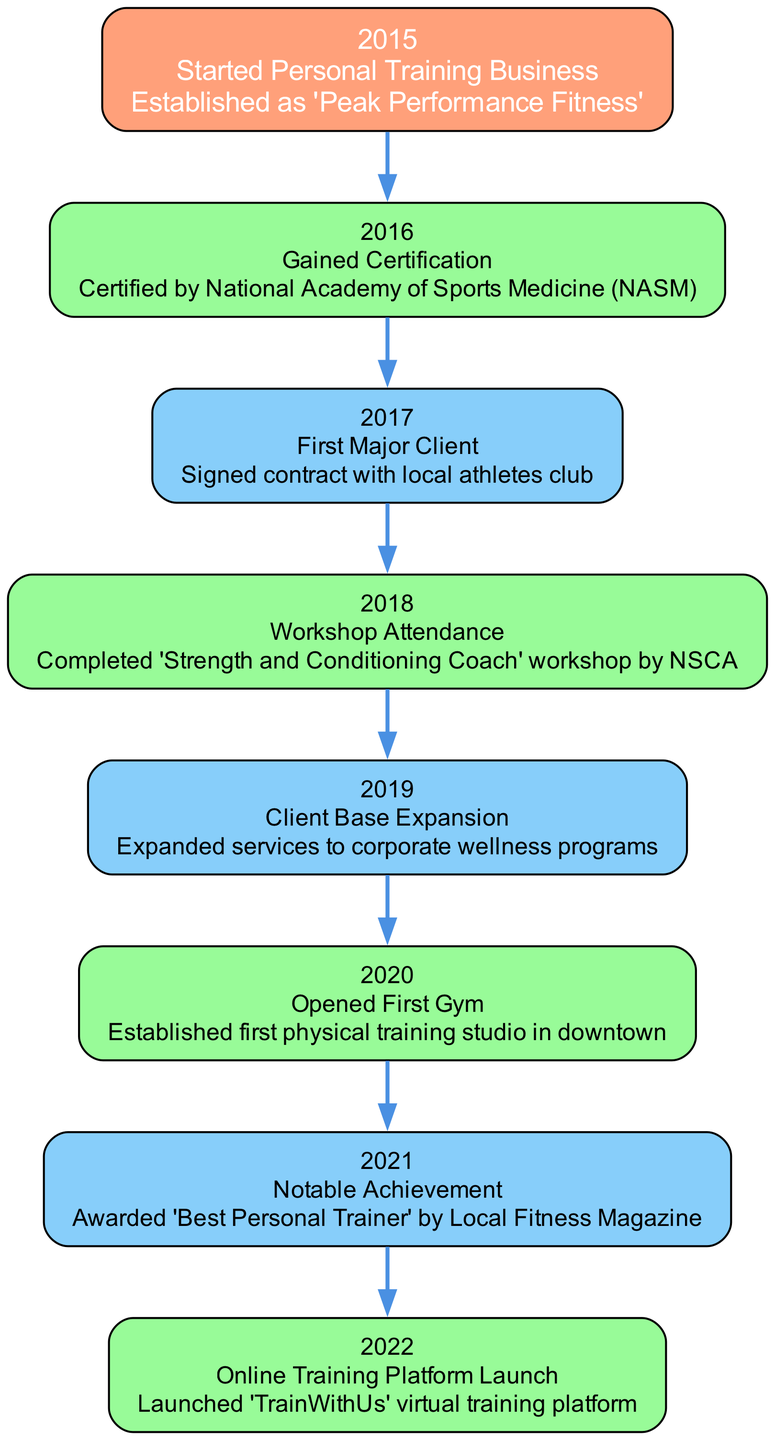What year was the personal training business started? The diagram indicates that the inception of the personal training business occurred in 2015. This can be found at the top node labeled "Inception."
Answer: 2015 How many milestones are listed in the diagram? The diagram contains a total of 7 milestones, including the inception year. Counting the milestone nodes from the diagram shows each significant event in the growth timeline after the inception year.
Answer: 7 What event took place in 2019? The diagram specifically states the event in 2019 is "Client Base Expansion." This node outlines the growth phase in which the business expanded its services.
Answer: Client Base Expansion What was the notable achievement in 2021? The diagram reveals that the notable achievement in 2021 was being awarded "Best Personal Trainer" by Local Fitness Magazine. This information can be found in the corresponding milestone node.
Answer: Awarded 'Best Personal Trainer' What is the last milestone mentioned in the timeline? The final milestone listed in the diagram is the "Online Training Platform Launch," which occurred in the year 2022. This is indicated towards the bottom of the milestones sequence in the diagram.
Answer: Online Training Platform Launch Which workshop did the trainer complete in 2018? The diagram indicates that in 2018, the trainer completed the "Strength and Conditioning Coach" workshop by NSCA. This information is part of the milestone details for that year.
Answer: Strength and Conditioning Coach In which year did the first gym open? The diagram indicates that the first gym was opened in 2020. This detail can be found under the milestone node for that specific year.
Answer: 2020 How does the event of gaining certification relate to the first major client? The diagram demonstrates that gaining certification in 2016 preceded the signing of the first major client in 2017. This shows a chronological connection where certification likely contributed to gaining that client.
Answer: Preceded 